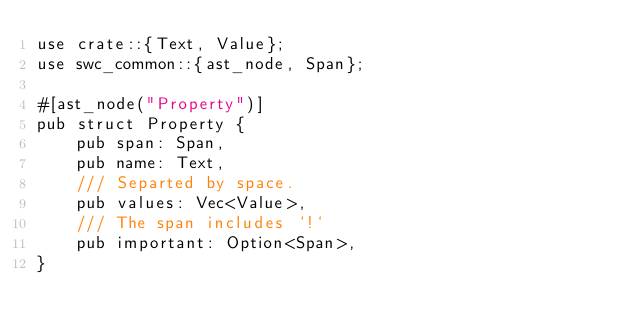<code> <loc_0><loc_0><loc_500><loc_500><_Rust_>use crate::{Text, Value};
use swc_common::{ast_node, Span};

#[ast_node("Property")]
pub struct Property {
    pub span: Span,
    pub name: Text,
    /// Separted by space.
    pub values: Vec<Value>,
    /// The span includes `!`
    pub important: Option<Span>,
}
</code> 